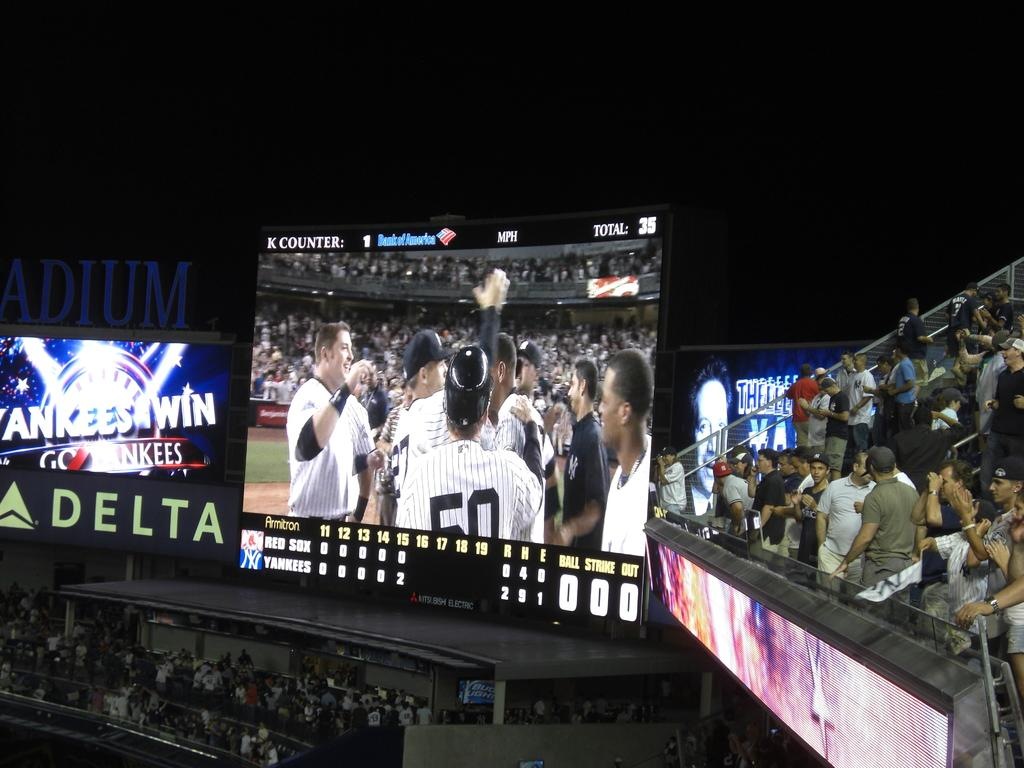<image>
Relay a brief, clear account of the picture shown. a scoreboard with a team on it with one guy wearing 50 